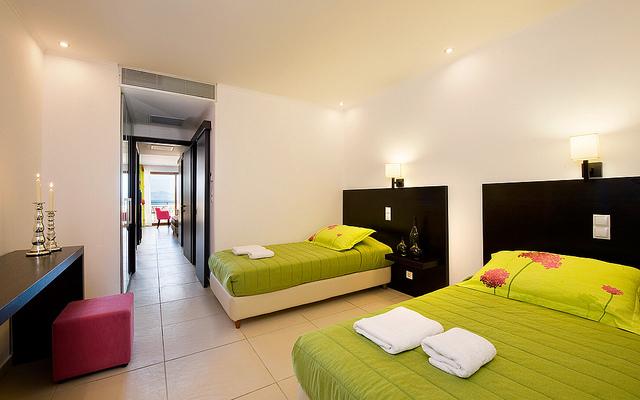How many towels are on each bed?
Quick response, please. 2. What room is this?
Concise answer only. Bedroom. How many people can sleep in this room?
Short answer required. 3. 